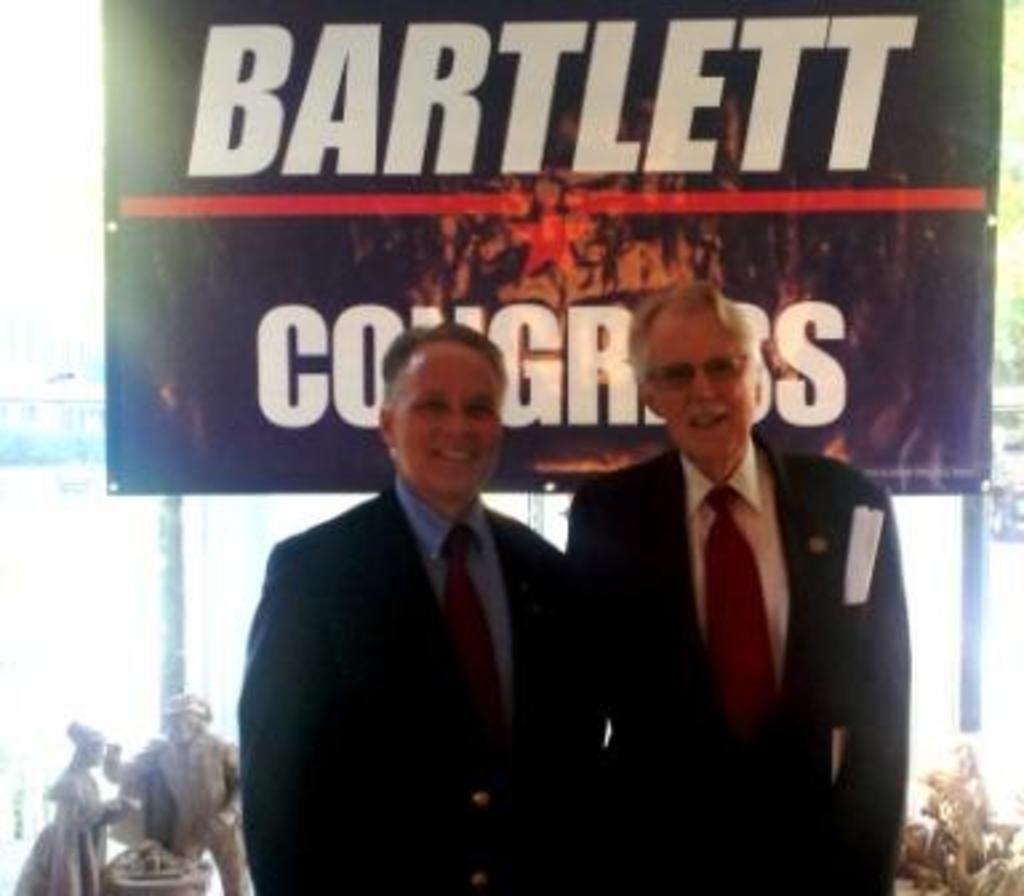Please provide a concise description of this image. In the image we can see two men standing, wearing clothes and they are smiling. The right side man is wearing spectacles. Behind them there is a board and text on it. Here we can see the sculpture and the tree. 